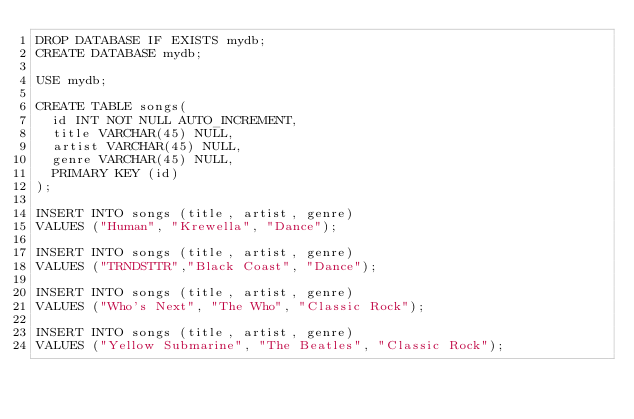<code> <loc_0><loc_0><loc_500><loc_500><_SQL_>DROP DATABASE IF EXISTS mydb;
CREATE DATABASE mydb;

USE mydb;

CREATE TABLE songs(
  id INT NOT NULL AUTO_INCREMENT,
  title VARCHAR(45) NULL,
  artist VARCHAR(45) NULL,
  genre VARCHAR(45) NULL,
  PRIMARY KEY (id)
);

INSERT INTO songs (title, artist, genre)
VALUES ("Human", "Krewella", "Dance");

INSERT INTO songs (title, artist, genre)
VALUES ("TRNDSTTR","Black Coast", "Dance");

INSERT INTO songs (title, artist, genre)
VALUES ("Who's Next", "The Who", "Classic Rock");

INSERT INTO songs (title, artist, genre)
VALUES ("Yellow Submarine", "The Beatles", "Classic Rock");</code> 